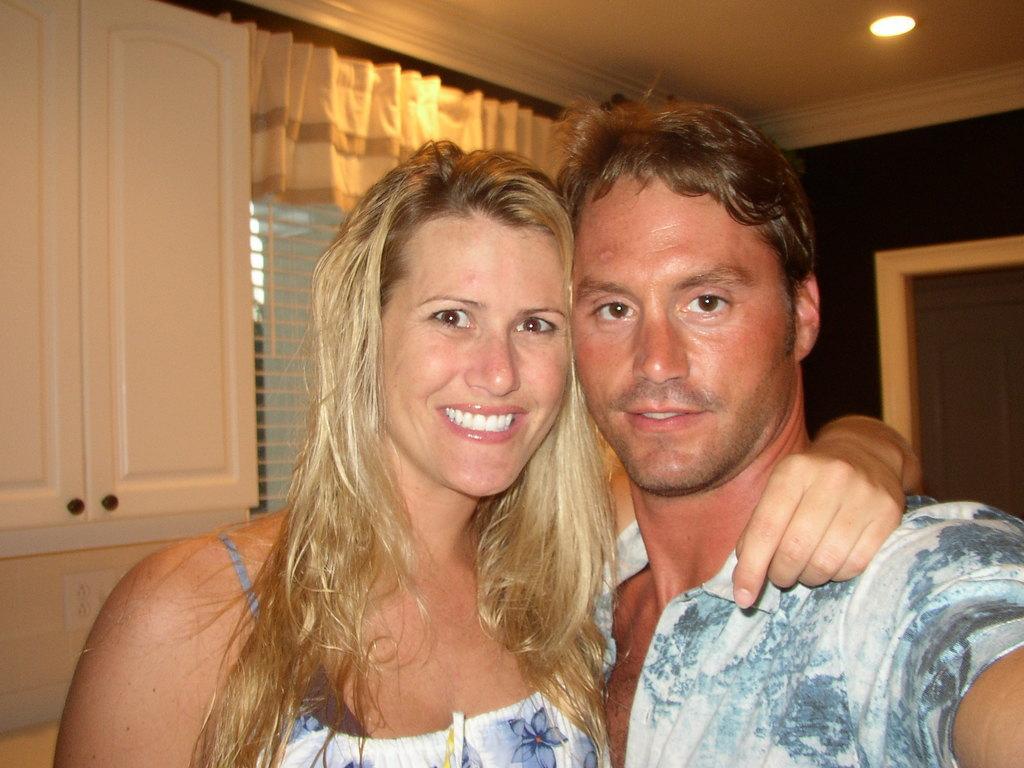Can you describe this image briefly? In this image on the right, there is a man, he wears a shirt. In the middle there is a woman, she wears a dress, her hair is short, she is smiling. In the background there are curtains, cupboards, window, lights and wall. 